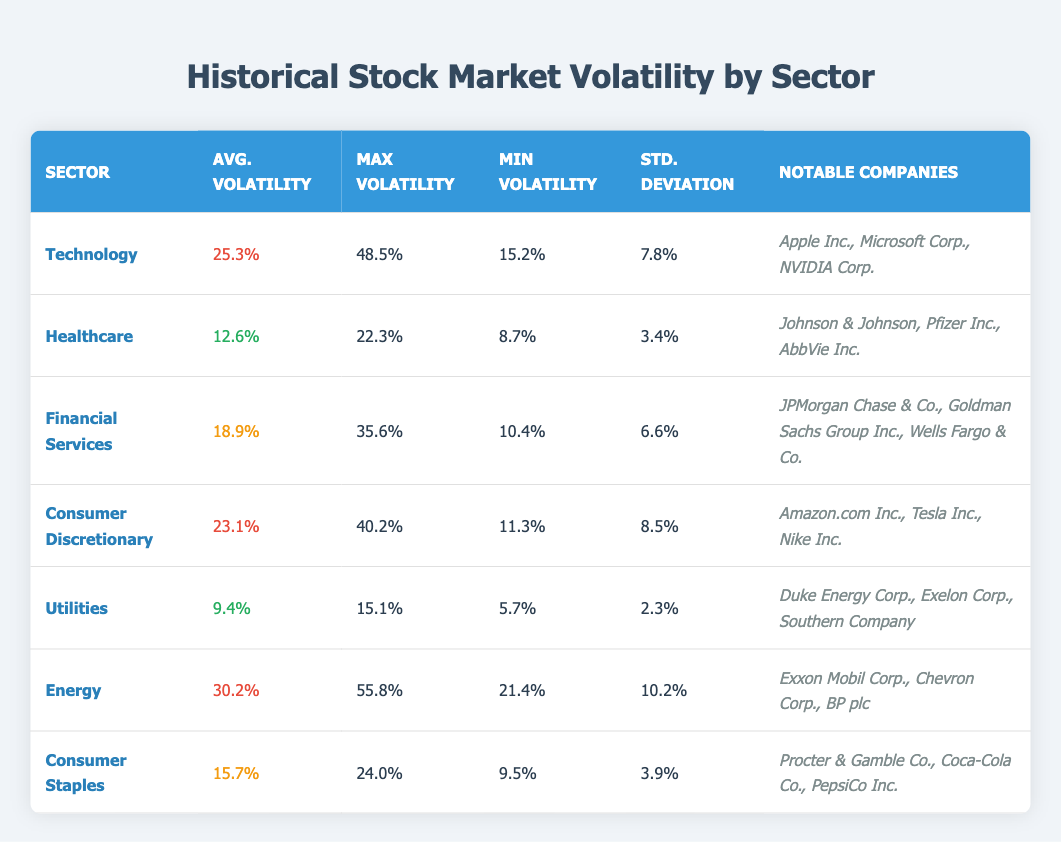What is the average volatility for the Energy sector? The table indicates that the average volatility for the Energy sector is listed under the "Avg. Volatility" column, which shows a value of 30.2%.
Answer: 30.2% Which sector has the lowest standard deviation? By examining the "Std. Deviation" column for each sector, the Utilities sector has the lowest value of 2.3%, as all other sectors have higher standard deviation figures.
Answer: Utilities Is the max volatility for the Financial Services sector higher than that of the Healthcare sector? Comparing the "Max Volatility" values, Financial Services has a max volatility of 35.6%, while Healthcare has 22.3%. Since 35.6% is greater than 22.3%, the statement is true.
Answer: Yes What is the average volatility across the Technology and Consumer Discretionary sectors combined? The average volatilities for Technology and Consumer Discretionary are 25.3% and 23.1%, respectively. To find the average of these two sectors, add them (25.3 + 23.1 = 48.4) and divide by 2. Thus, the average is 48.4 / 2 = 24.2%.
Answer: 24.2% Which sector has the highest minimum volatility? Looking at the "Min Volatility" column, we can see that the Energy sector has the highest minimum volatility at 21.4%, even higher than the next highest sector.
Answer: Energy Are there companies listed under the Consumer Staples sector that have a higher average volatility than the those under the Healthcare sector? The average volatility for Consumer Staples is 15.7%, while for Healthcare it is 12.6%. This indicates that Consumer Staples has a higher average volatility than Healthcare, confirming the statement is true.
Answer: Yes What is the difference in standard deviation between the Technology and Utilities sectors? The standard deviation for Technology is 7.8%, and for Utilities, it is 2.3%. The difference is calculated by subtracting the standard deviation of Utilities from that of Technology (7.8 - 2.3 = 5.5%).
Answer: 5.5% How many notable companies are listed under the Energy sector? The table shows that the Energy sector lists three notable companies: Exxon Mobil Corp., Chevron Corp., and BP plc.
Answer: 3 Is it true that the Healthcare sector has a max volatility figure higher than that of Consumer Discretionary? By comparing the "Max Volatility" values, Healthcare has a max volatility of 22.3%, while Consumer Discretionary has 40.2%. Since 22.3% is less than 40.2%, the statement is false.
Answer: No 